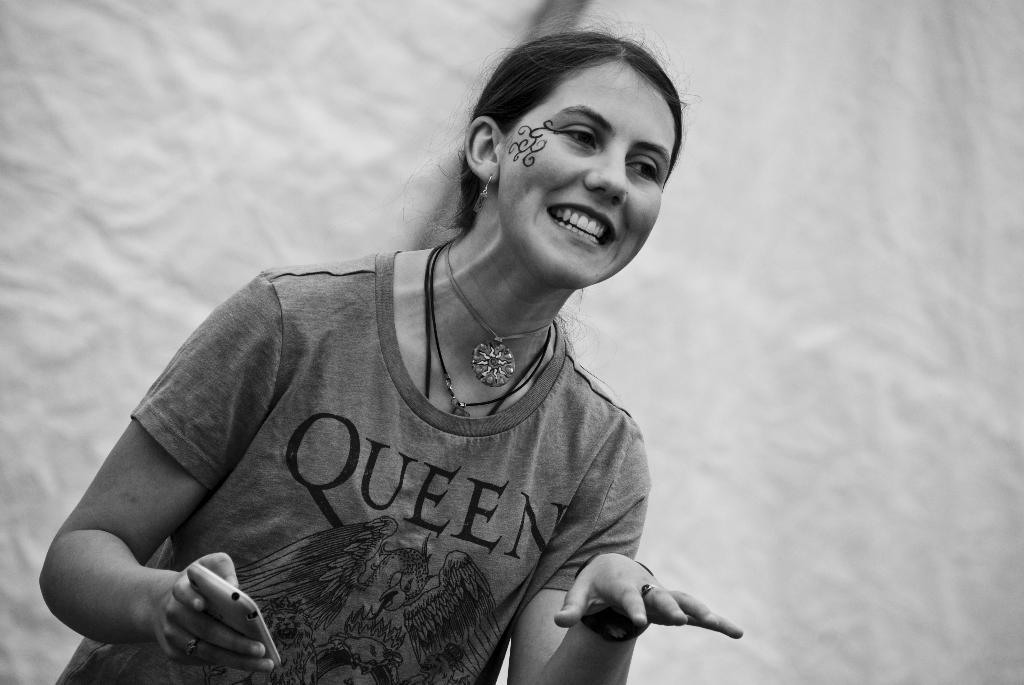Who is the main subject in the image? There is a woman in the image. What is the woman holding in the image? The woman is holding a mobile in the image. What can be seen in the background of the image? There is a wall in the background of the image. How many spots can be seen on the woman's dress in the image? There is no information about spots on the woman's dress in the image, so we cannot answer that question. 